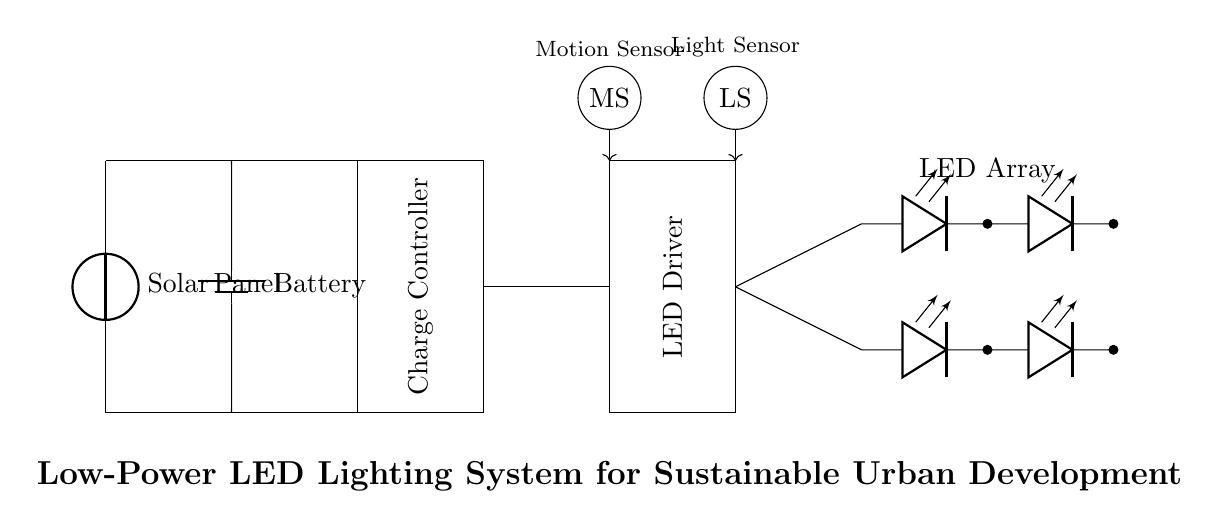What is the main power source for this circuit? The main power source is a solar panel located at the beginning of the circuit diagram, which is indicated as a voltage source.
Answer: Solar Panel What components are used to control the LED output? The LED output is controlled by two main components: the LED driver, which delivers the required power to the LEDs, and the charge controller, which manages the energy from the solar panel.
Answer: LED Driver and Charge Controller How many LEDs are in the array? There are a total of six LEDs shown in the LED array, arranged in two rows of three.
Answer: Six What role does the motion sensor play in this circuit? The motion sensor, indicated as "MS," detects movement and can trigger the lighting system to activate or adjust, helping to conserve power when no one is present.
Answer: Activates light What is the function of the light sensor in the circuit? The light sensor, indicated as "LS," measures ambient light levels and can help determine if the LEDs should be on or off based on surrounding light conditions, contributing to energy savings.
Answer: Measures ambient light What type of energy storage is utilized in this system? The circuit employs a battery as its energy storage component, which stores energy collected from the solar panel for use when needed, especially during low light conditions.
Answer: Battery Why is this lighting system considered low power? This system is considered low power due to its reliance on energy-efficient LED technology, solar power generation, and the incorporation of sensors to minimize energy waste.
Answer: Energy-efficient design 